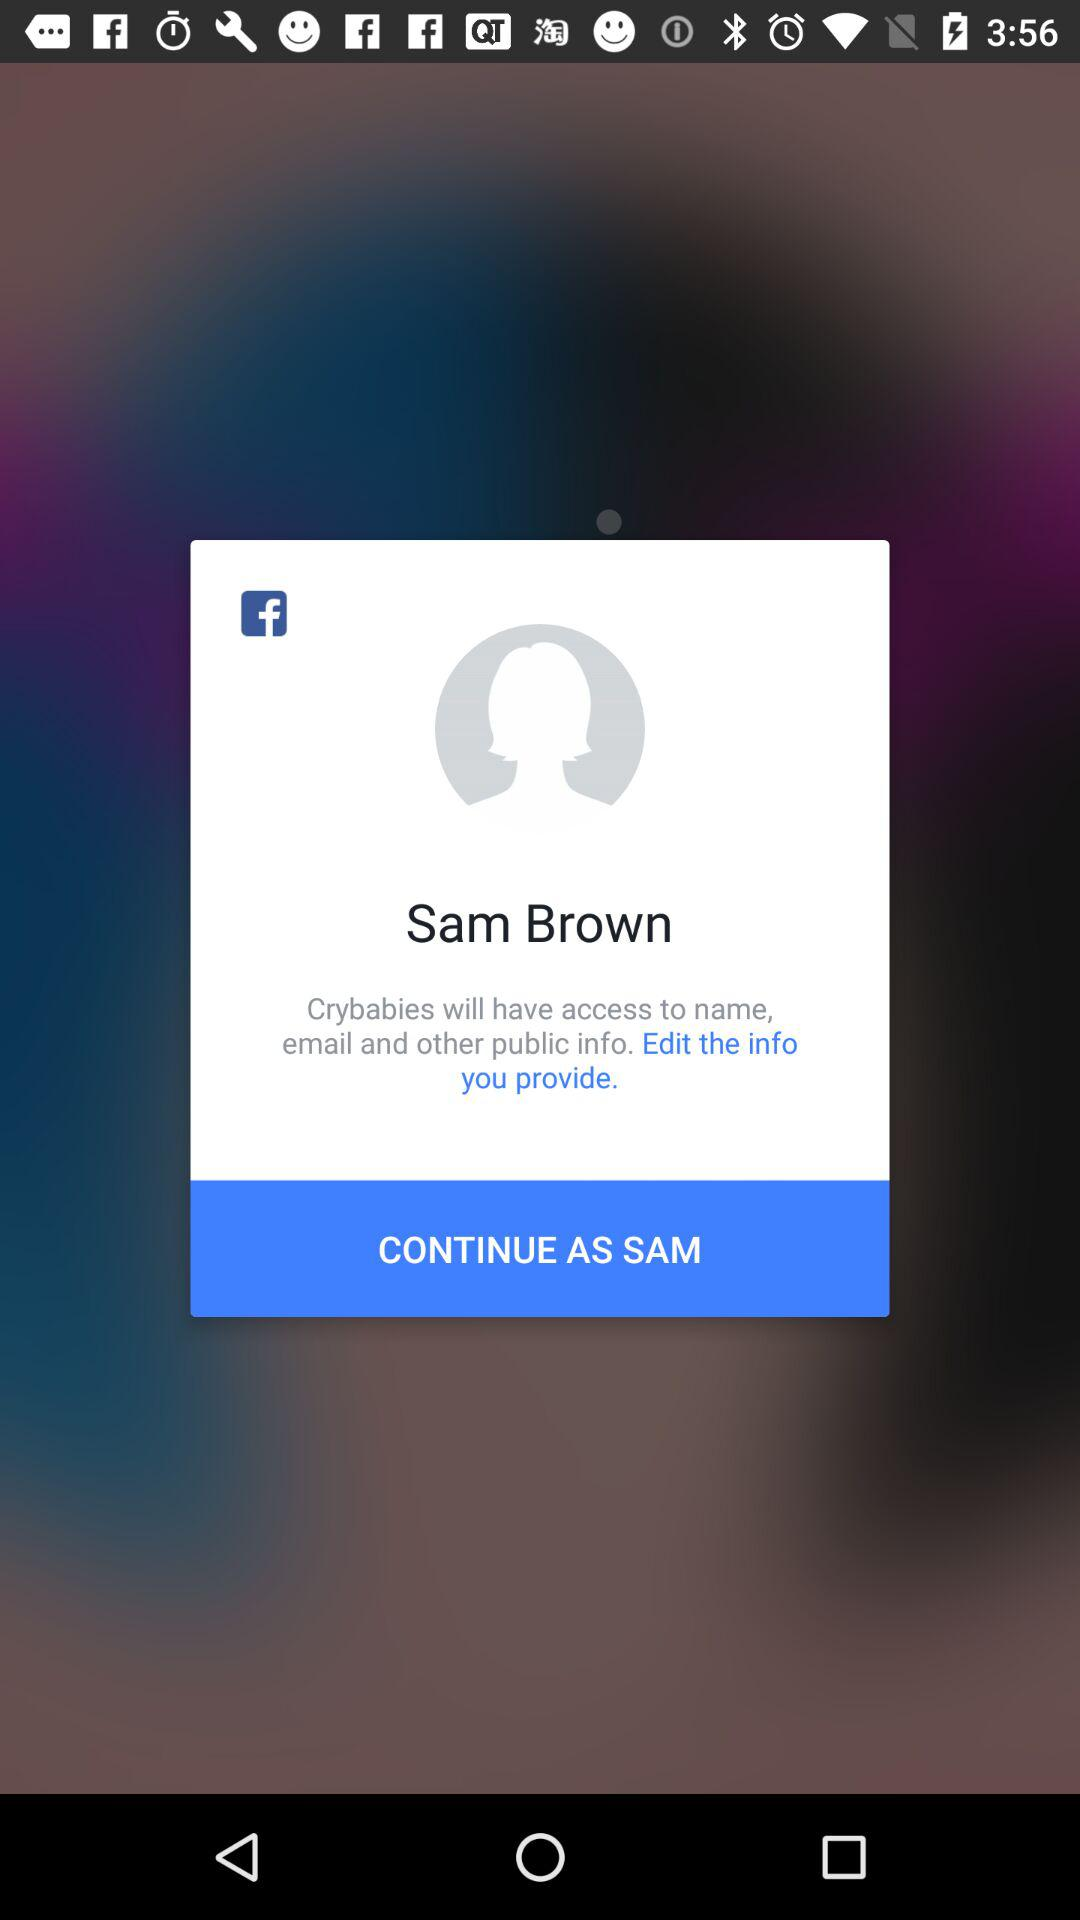Through what application can a user log in with? The application through which a user can login is Facebook. 